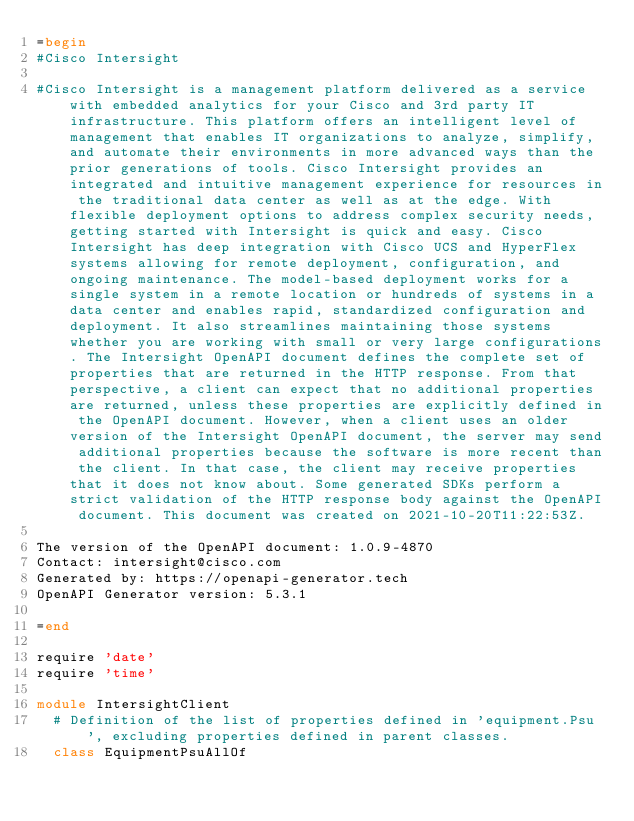<code> <loc_0><loc_0><loc_500><loc_500><_Ruby_>=begin
#Cisco Intersight

#Cisco Intersight is a management platform delivered as a service with embedded analytics for your Cisco and 3rd party IT infrastructure. This platform offers an intelligent level of management that enables IT organizations to analyze, simplify, and automate their environments in more advanced ways than the prior generations of tools. Cisco Intersight provides an integrated and intuitive management experience for resources in the traditional data center as well as at the edge. With flexible deployment options to address complex security needs, getting started with Intersight is quick and easy. Cisco Intersight has deep integration with Cisco UCS and HyperFlex systems allowing for remote deployment, configuration, and ongoing maintenance. The model-based deployment works for a single system in a remote location or hundreds of systems in a data center and enables rapid, standardized configuration and deployment. It also streamlines maintaining those systems whether you are working with small or very large configurations. The Intersight OpenAPI document defines the complete set of properties that are returned in the HTTP response. From that perspective, a client can expect that no additional properties are returned, unless these properties are explicitly defined in the OpenAPI document. However, when a client uses an older version of the Intersight OpenAPI document, the server may send additional properties because the software is more recent than the client. In that case, the client may receive properties that it does not know about. Some generated SDKs perform a strict validation of the HTTP response body against the OpenAPI document. This document was created on 2021-10-20T11:22:53Z.

The version of the OpenAPI document: 1.0.9-4870
Contact: intersight@cisco.com
Generated by: https://openapi-generator.tech
OpenAPI Generator version: 5.3.1

=end

require 'date'
require 'time'

module IntersightClient
  # Definition of the list of properties defined in 'equipment.Psu', excluding properties defined in parent classes.
  class EquipmentPsuAllOf</code> 